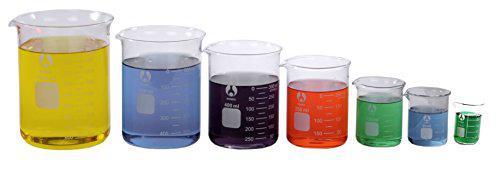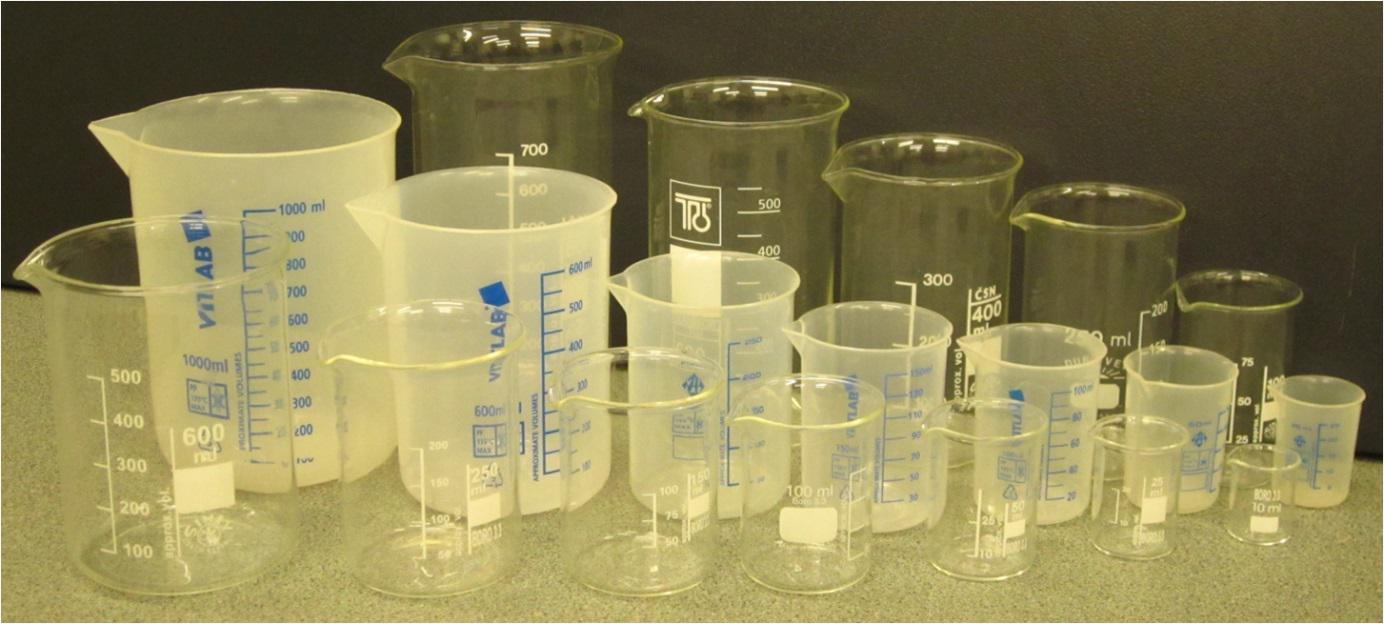The first image is the image on the left, the second image is the image on the right. Examine the images to the left and right. Is the description "At least 7 beakers of varying sizes are filled with colorful liquid." accurate? Answer yes or no. Yes. The first image is the image on the left, the second image is the image on the right. For the images displayed, is the sentence "The left and right image contains a total of eight beakers." factually correct? Answer yes or no. No. 